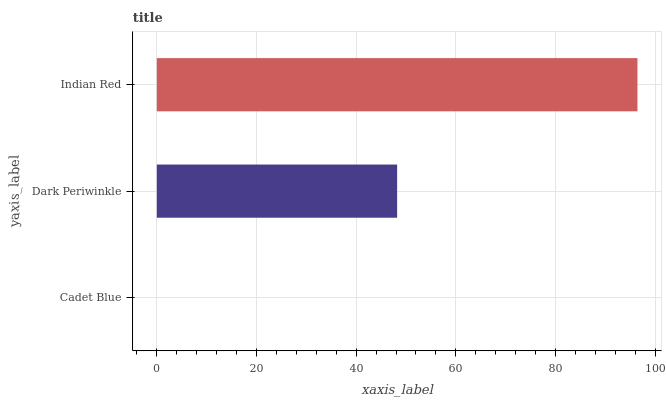Is Cadet Blue the minimum?
Answer yes or no. Yes. Is Indian Red the maximum?
Answer yes or no. Yes. Is Dark Periwinkle the minimum?
Answer yes or no. No. Is Dark Periwinkle the maximum?
Answer yes or no. No. Is Dark Periwinkle greater than Cadet Blue?
Answer yes or no. Yes. Is Cadet Blue less than Dark Periwinkle?
Answer yes or no. Yes. Is Cadet Blue greater than Dark Periwinkle?
Answer yes or no. No. Is Dark Periwinkle less than Cadet Blue?
Answer yes or no. No. Is Dark Periwinkle the high median?
Answer yes or no. Yes. Is Dark Periwinkle the low median?
Answer yes or no. Yes. Is Cadet Blue the high median?
Answer yes or no. No. Is Cadet Blue the low median?
Answer yes or no. No. 